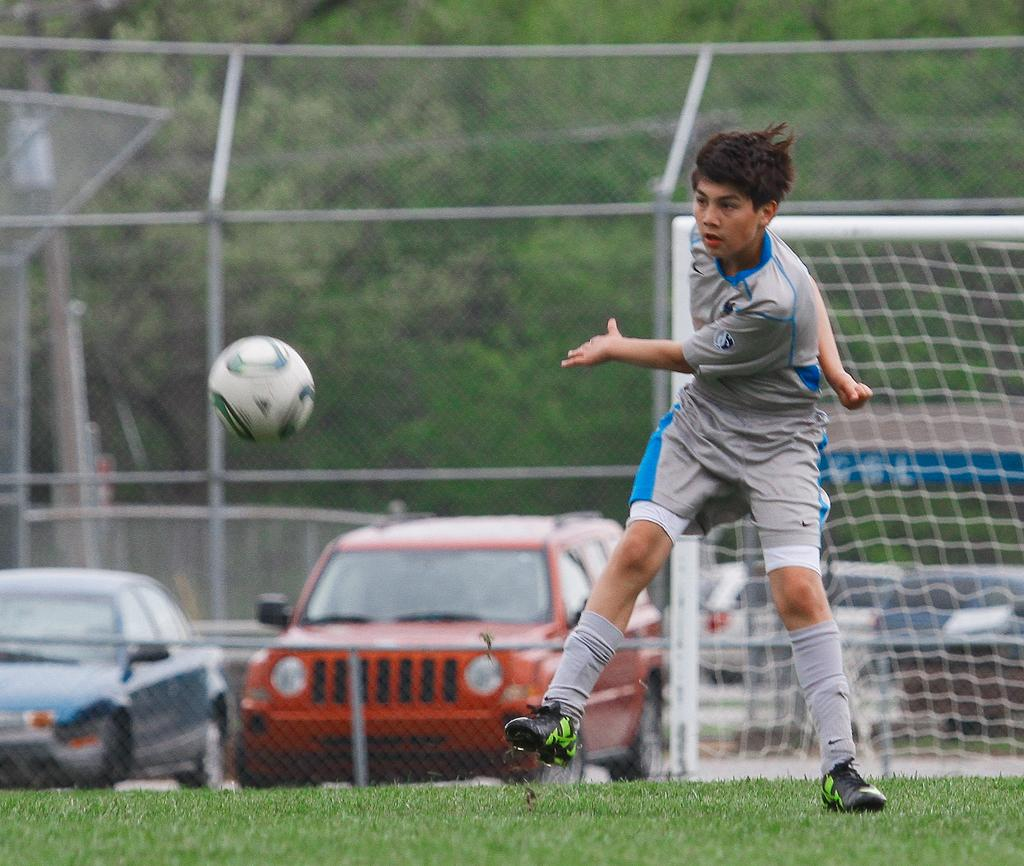What is located in the foreground of the picture? There is a person and a ball in the foreground of the picture. What type of surface is visible in the foreground of the picture? There is grass in the foreground of the picture. What can be seen in the middle of the picture? There are vehicles, a goal post, and fencing in the middle of the picture. What is visible in the background of the picture? There is greenery in the background of the picture. Where is the swing located in the image? There is no swing present in the image. What type of animals can be seen at the zoo in the image? There is no zoo present in the image. 